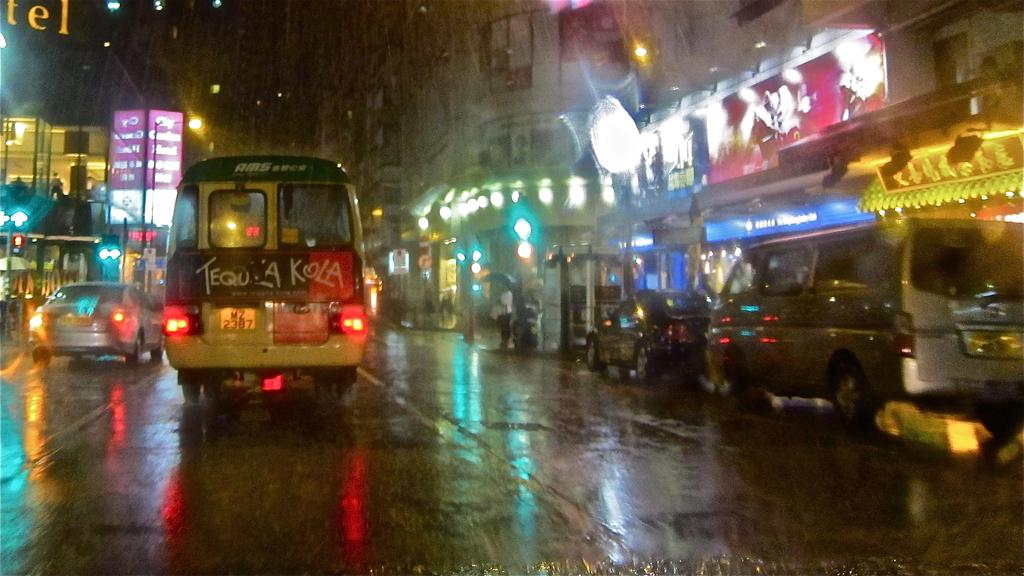<image>
Provide a brief description of the given image. A bus on a wet street and it says Tequ A Kola on the back 